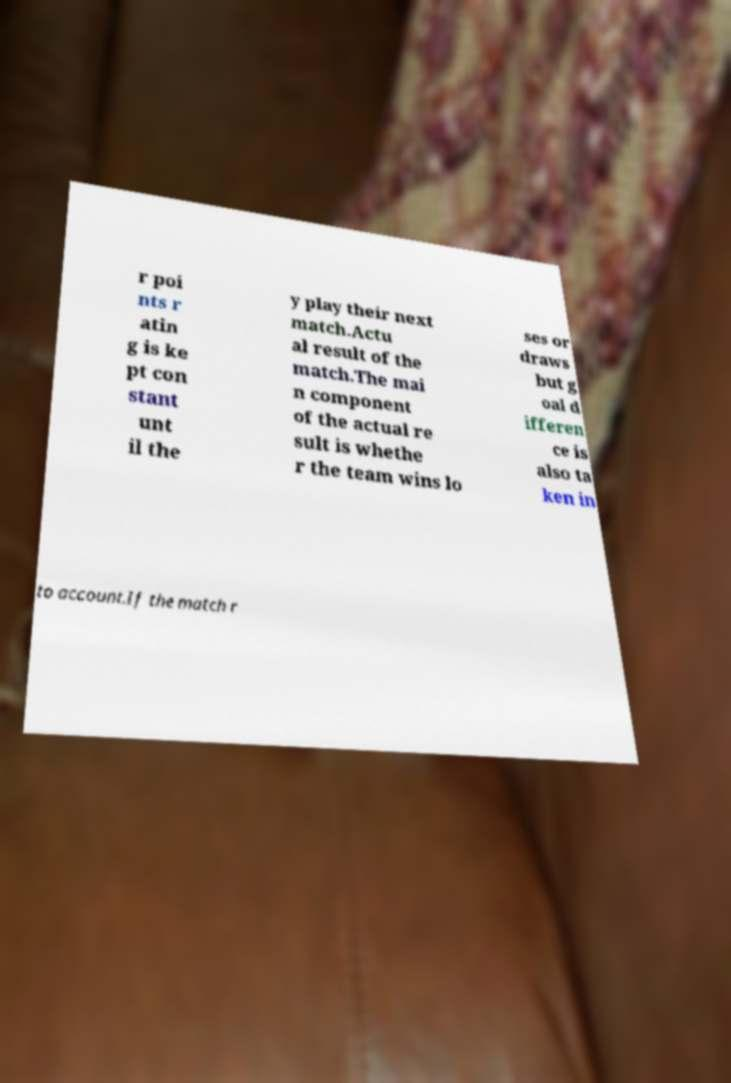What messages or text are displayed in this image? I need them in a readable, typed format. r poi nts r atin g is ke pt con stant unt il the y play their next match.Actu al result of the match.The mai n component of the actual re sult is whethe r the team wins lo ses or draws but g oal d ifferen ce is also ta ken in to account.If the match r 